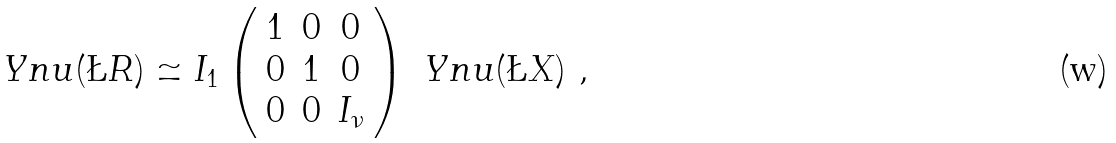<formula> <loc_0><loc_0><loc_500><loc_500>\ Y n u ( \L R ) \simeq I _ { 1 } \left ( \begin{array} { c c c } 1 & 0 & 0 \\ 0 & 1 & 0 \\ 0 & 0 & I _ { \nu } \end{array} \right ) \ Y n u ( \L X ) \ ,</formula> 